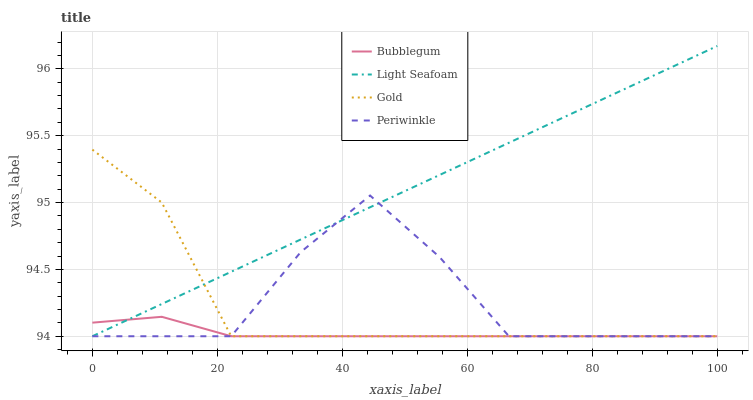Does Bubblegum have the minimum area under the curve?
Answer yes or no. Yes. Does Light Seafoam have the maximum area under the curve?
Answer yes or no. Yes. Does Periwinkle have the minimum area under the curve?
Answer yes or no. No. Does Periwinkle have the maximum area under the curve?
Answer yes or no. No. Is Light Seafoam the smoothest?
Answer yes or no. Yes. Is Periwinkle the roughest?
Answer yes or no. Yes. Is Gold the smoothest?
Answer yes or no. No. Is Gold the roughest?
Answer yes or no. No. Does Light Seafoam have the lowest value?
Answer yes or no. Yes. Does Light Seafoam have the highest value?
Answer yes or no. Yes. Does Periwinkle have the highest value?
Answer yes or no. No. Does Bubblegum intersect Periwinkle?
Answer yes or no. Yes. Is Bubblegum less than Periwinkle?
Answer yes or no. No. Is Bubblegum greater than Periwinkle?
Answer yes or no. No. 